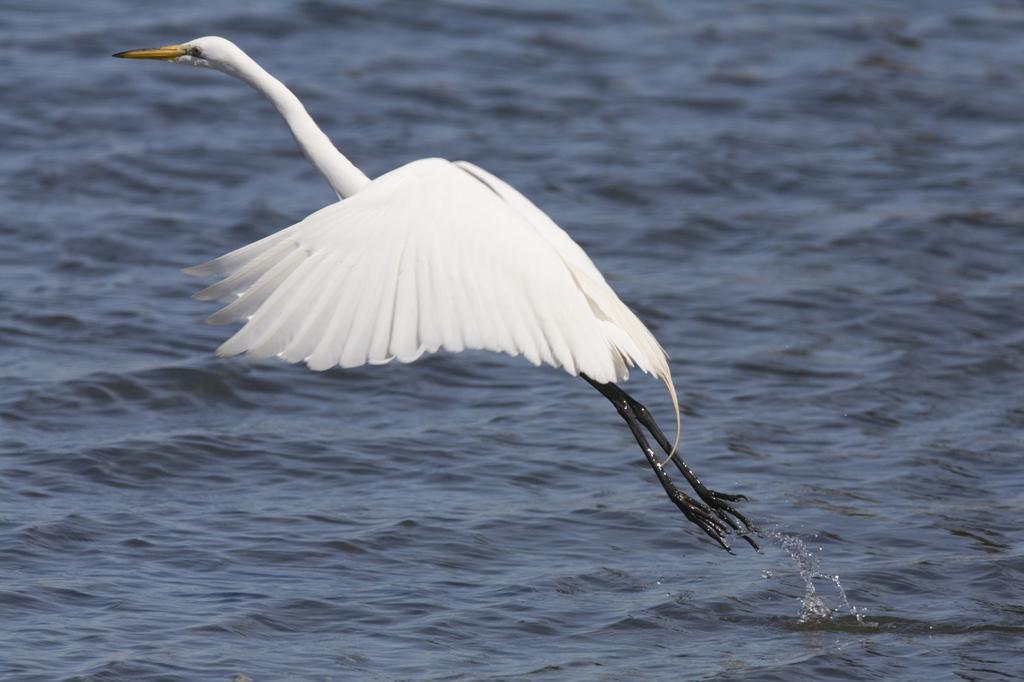How would you summarize this image in a sentence or two? In this picture I can see a white bird flying above the water. 